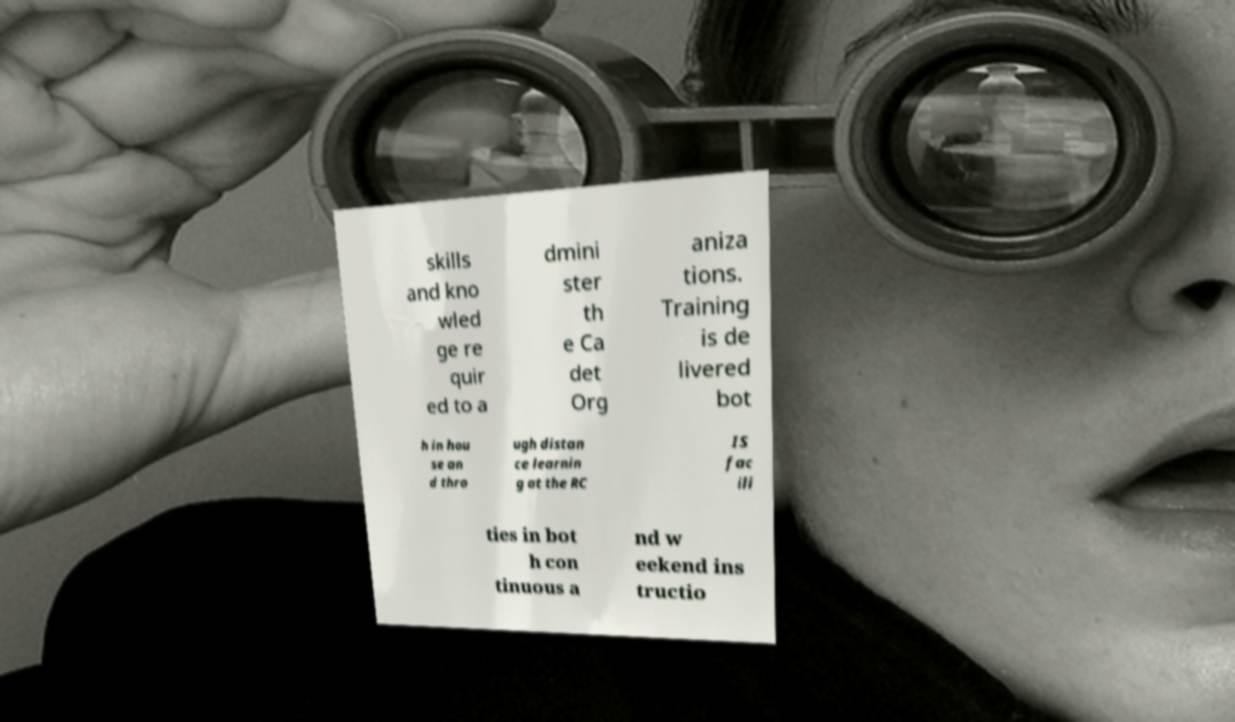Please identify and transcribe the text found in this image. skills and kno wled ge re quir ed to a dmini ster th e Ca det Org aniza tions. Training is de livered bot h in hou se an d thro ugh distan ce learnin g at the RC IS fac ili ties in bot h con tinuous a nd w eekend ins tructio 